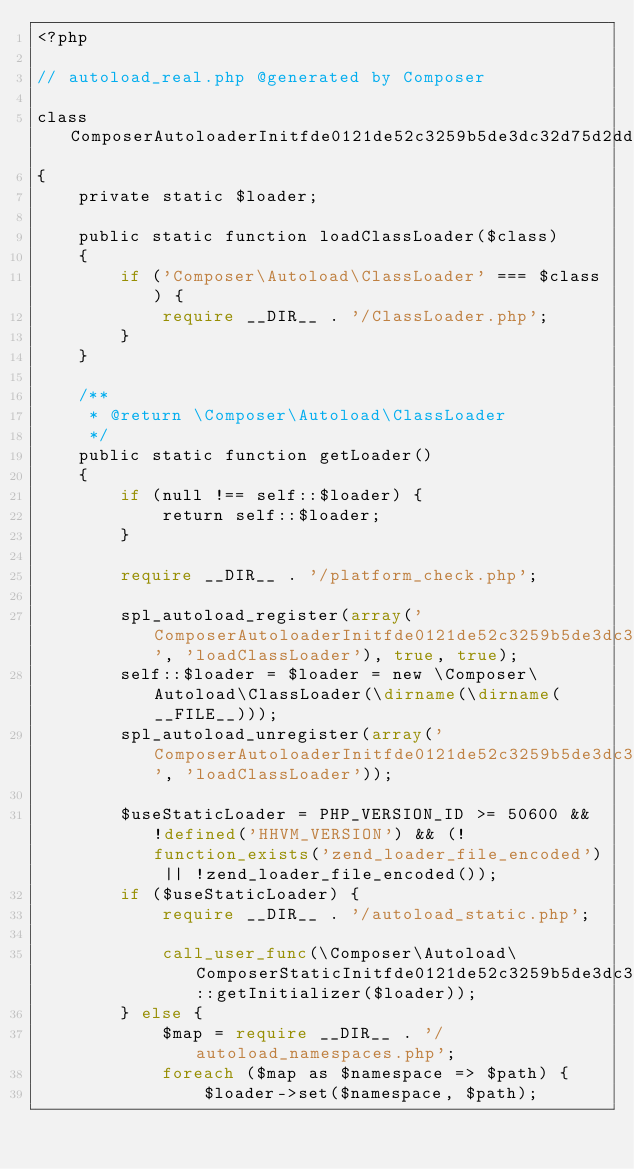Convert code to text. <code><loc_0><loc_0><loc_500><loc_500><_PHP_><?php

// autoload_real.php @generated by Composer

class ComposerAutoloaderInitfde0121de52c3259b5de3dc32d75d2dd
{
    private static $loader;

    public static function loadClassLoader($class)
    {
        if ('Composer\Autoload\ClassLoader' === $class) {
            require __DIR__ . '/ClassLoader.php';
        }
    }

    /**
     * @return \Composer\Autoload\ClassLoader
     */
    public static function getLoader()
    {
        if (null !== self::$loader) {
            return self::$loader;
        }

        require __DIR__ . '/platform_check.php';

        spl_autoload_register(array('ComposerAutoloaderInitfde0121de52c3259b5de3dc32d75d2dd', 'loadClassLoader'), true, true);
        self::$loader = $loader = new \Composer\Autoload\ClassLoader(\dirname(\dirname(__FILE__)));
        spl_autoload_unregister(array('ComposerAutoloaderInitfde0121de52c3259b5de3dc32d75d2dd', 'loadClassLoader'));

        $useStaticLoader = PHP_VERSION_ID >= 50600 && !defined('HHVM_VERSION') && (!function_exists('zend_loader_file_encoded') || !zend_loader_file_encoded());
        if ($useStaticLoader) {
            require __DIR__ . '/autoload_static.php';

            call_user_func(\Composer\Autoload\ComposerStaticInitfde0121de52c3259b5de3dc32d75d2dd::getInitializer($loader));
        } else {
            $map = require __DIR__ . '/autoload_namespaces.php';
            foreach ($map as $namespace => $path) {
                $loader->set($namespace, $path);</code> 